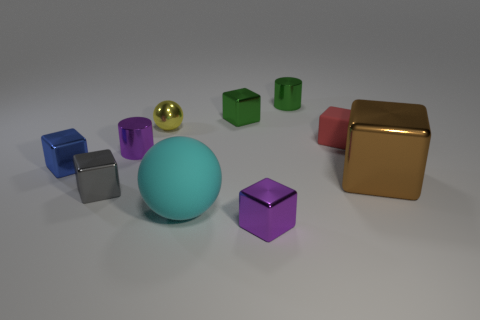Subtract all tiny red cubes. How many cubes are left? 5 Subtract all yellow spheres. How many spheres are left? 1 Subtract 2 spheres. How many spheres are left? 0 Subtract all purple cylinders. How many purple blocks are left? 1 Subtract all balls. How many objects are left? 8 Subtract all large green matte spheres. Subtract all small blocks. How many objects are left? 5 Add 5 metal spheres. How many metal spheres are left? 6 Add 5 tiny green metallic objects. How many tiny green metallic objects exist? 7 Subtract 0 blue spheres. How many objects are left? 10 Subtract all green cylinders. Subtract all cyan blocks. How many cylinders are left? 1 